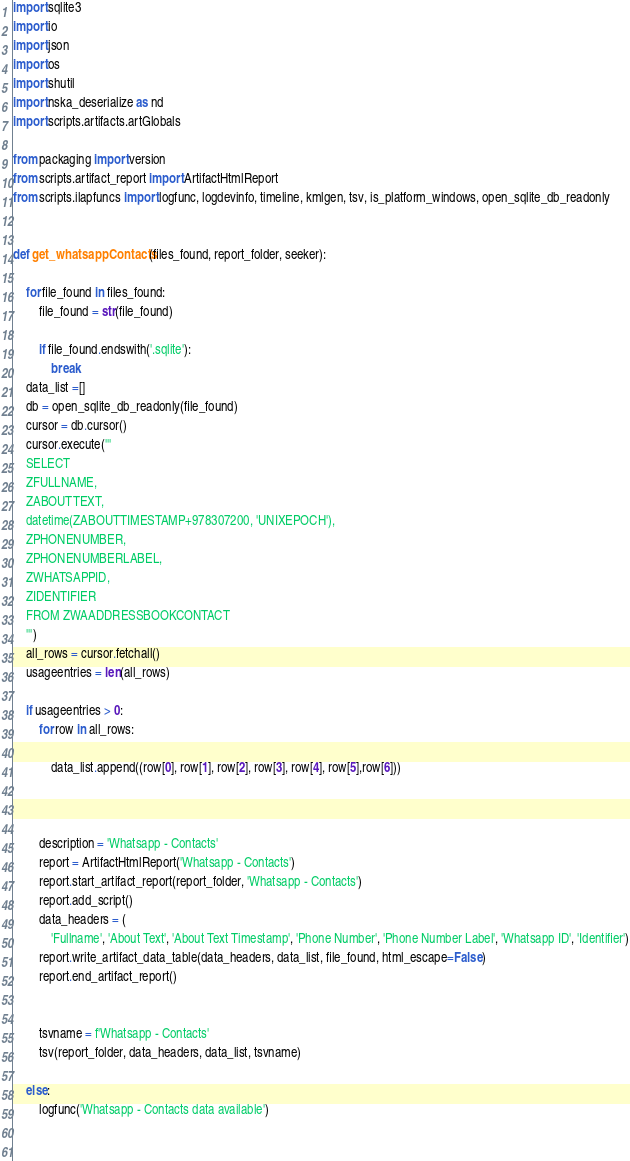<code> <loc_0><loc_0><loc_500><loc_500><_Python_>import sqlite3
import io
import json
import os
import shutil
import nska_deserialize as nd
import scripts.artifacts.artGlobals

from packaging import version
from scripts.artifact_report import ArtifactHtmlReport
from scripts.ilapfuncs import logfunc, logdevinfo, timeline, kmlgen, tsv, is_platform_windows, open_sqlite_db_readonly


def get_whatsappContacts(files_found, report_folder, seeker):
    
    for file_found in files_found:
        file_found = str(file_found)
        
        if file_found.endswith('.sqlite'):
            break
    data_list =[]
    db = open_sqlite_db_readonly(file_found)
    cursor = db.cursor()
    cursor.execute('''
    SELECT
    ZFULLNAME,
    ZABOUTTEXT,
    datetime(ZABOUTTIMESTAMP+978307200, 'UNIXEPOCH'),
    ZPHONENUMBER,
    ZPHONENUMBERLABEL,
    ZWHATSAPPID,
    ZIDENTIFIER
    FROM ZWAADDRESSBOOKCONTACT
    ''')
    all_rows = cursor.fetchall()
    usageentries = len(all_rows)
    
    if usageentries > 0:
        for row in all_rows:
            
            data_list.append((row[0], row[1], row[2], row[3], row[4], row[5],row[6]))
            
        
        
        description = 'Whatsapp - Contacts'
        report = ArtifactHtmlReport('Whatsapp - Contacts')
        report.start_artifact_report(report_folder, 'Whatsapp - Contacts')
        report.add_script()
        data_headers = (
            'Fullname', 'About Text', 'About Text Timestamp', 'Phone Number', 'Phone Number Label', 'Whatsapp ID', 'Identifier')
        report.write_artifact_data_table(data_headers, data_list, file_found, html_escape=False)
        report.end_artifact_report()    
        
        
        tsvname = f'Whatsapp - Contacts'
        tsv(report_folder, data_headers, data_list, tsvname)
        
    else:
        logfunc('Whatsapp - Contacts data available')
        
    </code> 